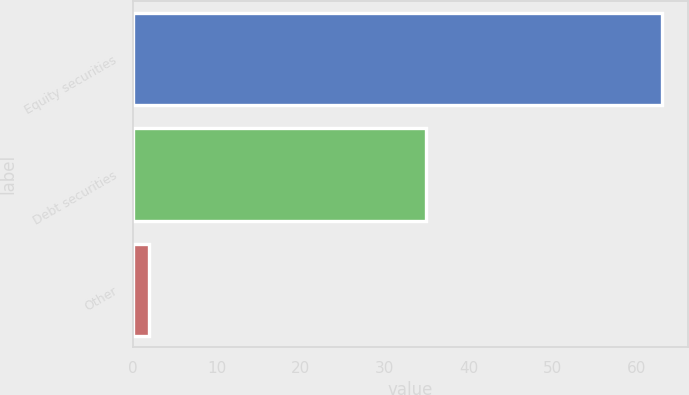Convert chart. <chart><loc_0><loc_0><loc_500><loc_500><bar_chart><fcel>Equity securities<fcel>Debt securities<fcel>Other<nl><fcel>63<fcel>35<fcel>2<nl></chart> 